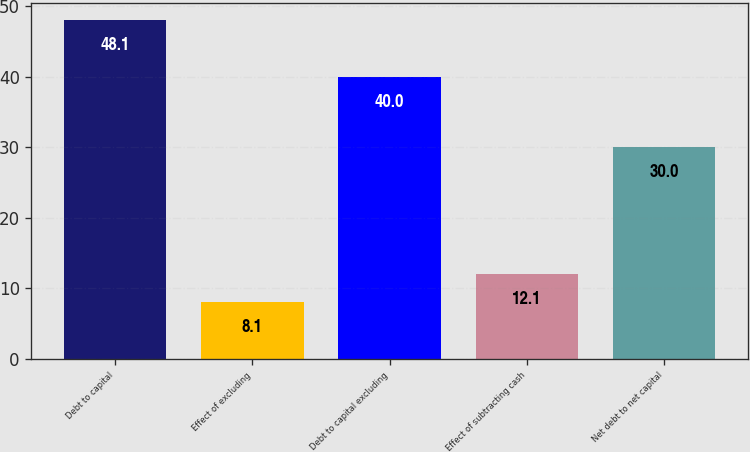Convert chart to OTSL. <chart><loc_0><loc_0><loc_500><loc_500><bar_chart><fcel>Debt to capital<fcel>Effect of excluding<fcel>Debt to capital excluding<fcel>Effect of subtracting cash<fcel>Net debt to net capital<nl><fcel>48.1<fcel>8.1<fcel>40<fcel>12.1<fcel>30<nl></chart> 